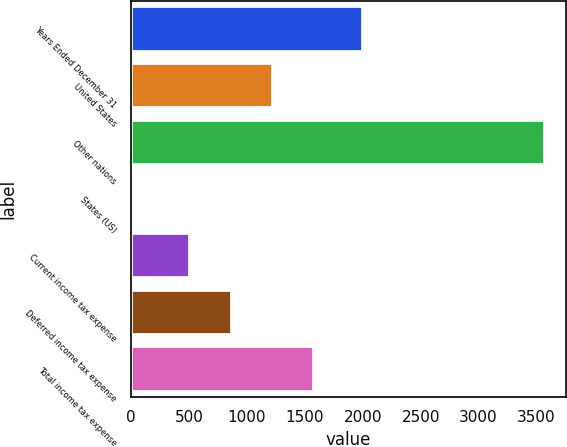Convert chart. <chart><loc_0><loc_0><loc_500><loc_500><bar_chart><fcel>Years Ended December 31<fcel>United States<fcel>Other nations<fcel>States (US)<fcel>Current income tax expense<fcel>Deferred income tax expense<fcel>Total income tax expense<nl><fcel>2006<fcel>1223.6<fcel>3576<fcel>13<fcel>511<fcel>867.3<fcel>1579.9<nl></chart> 